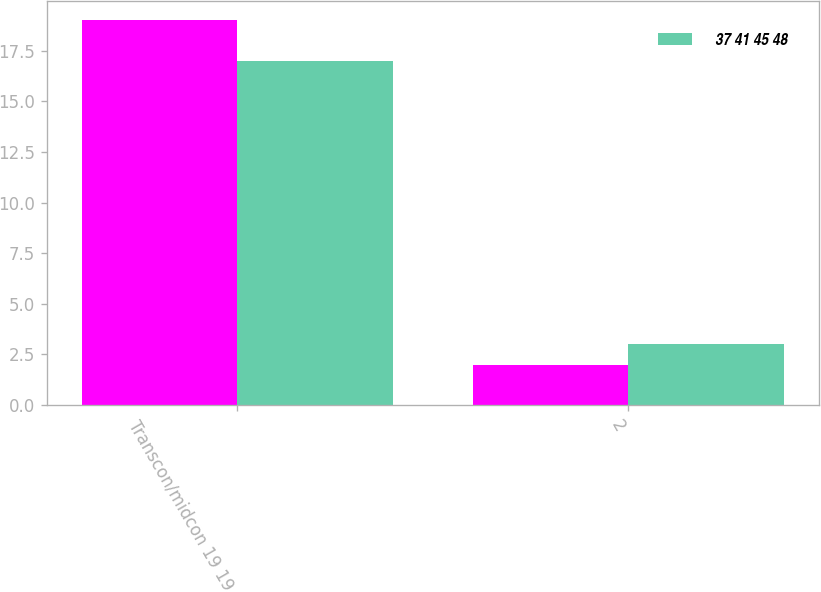<chart> <loc_0><loc_0><loc_500><loc_500><stacked_bar_chart><ecel><fcel>Transcon/midcon 19 19<fcel>2<nl><fcel>nan<fcel>19<fcel>2<nl><fcel>37 41 45 48<fcel>17<fcel>3<nl></chart> 